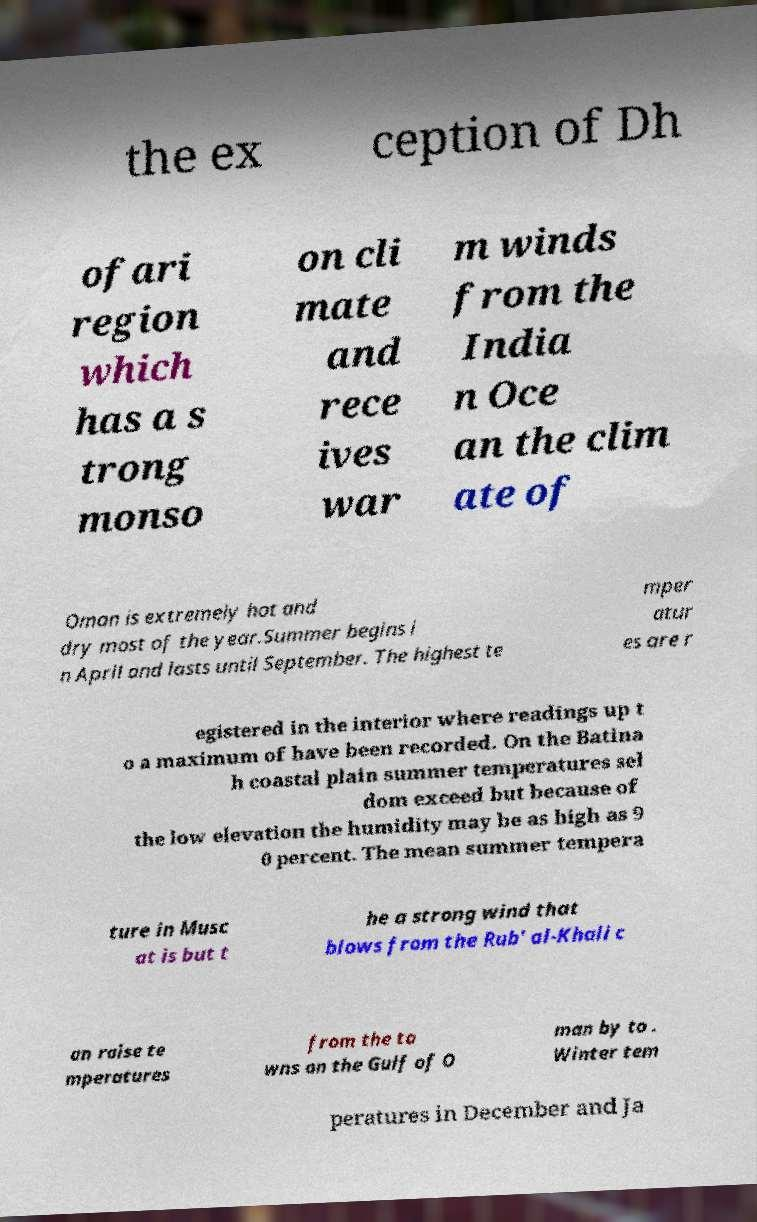Can you read and provide the text displayed in the image?This photo seems to have some interesting text. Can you extract and type it out for me? the ex ception of Dh ofari region which has a s trong monso on cli mate and rece ives war m winds from the India n Oce an the clim ate of Oman is extremely hot and dry most of the year.Summer begins i n April and lasts until September. The highest te mper atur es are r egistered in the interior where readings up t o a maximum of have been recorded. On the Batina h coastal plain summer temperatures sel dom exceed but because of the low elevation the humidity may be as high as 9 0 percent. The mean summer tempera ture in Musc at is but t he a strong wind that blows from the Rub' al-Khali c an raise te mperatures from the to wns on the Gulf of O man by to . Winter tem peratures in December and Ja 